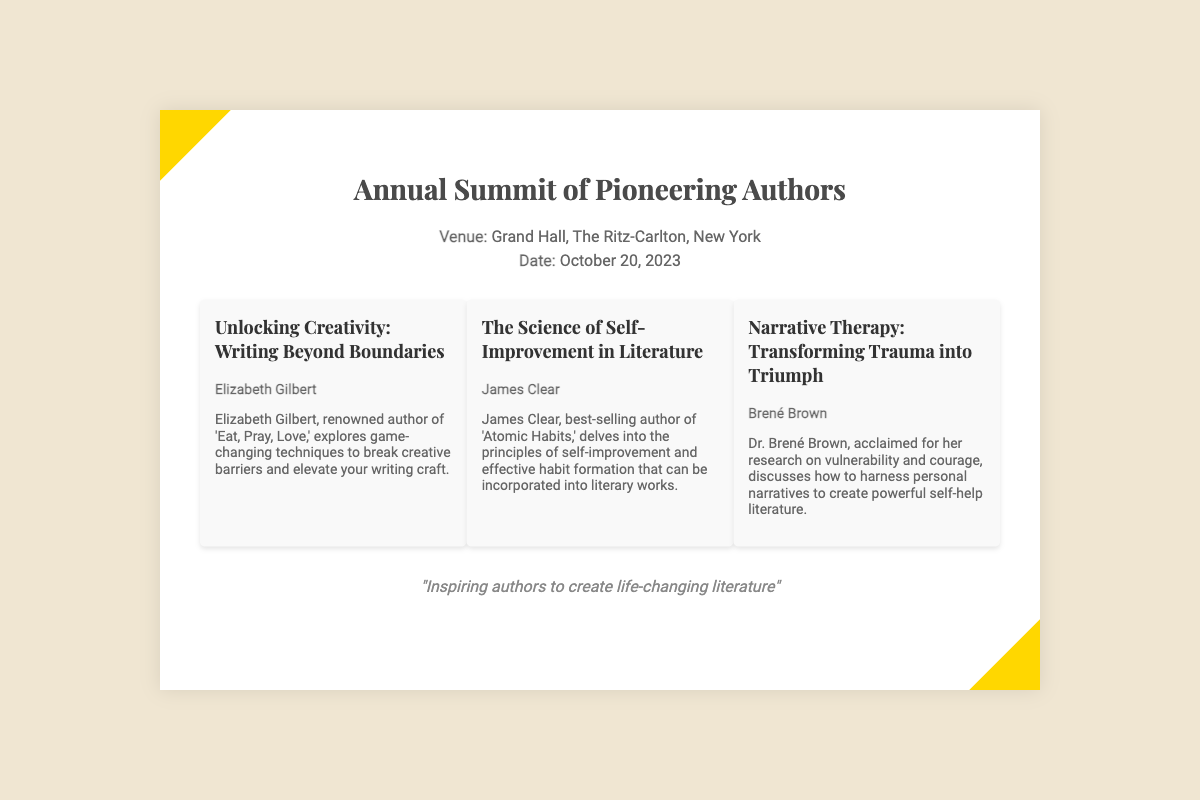What is the name of the event? The event is titled "Annual Summit of Pioneering Authors" as stated at the top of the document.
Answer: Annual Summit of Pioneering Authors Where is the event taking place? The venue is mentioned as "Grand Hall, The Ritz-Carlton, New York" in the document.
Answer: Grand Hall, The Ritz-Carlton, New York What date is the event scheduled for? The date is specified as "October 20, 2023" within the event details section.
Answer: October 20, 2023 Who is the speaker for the keynote on creativity? The keynote on creativity is presented by Elizabeth Gilbert, as indicated in the keynote section.
Answer: Elizabeth Gilbert What is the main topic of James Clear's keynote? James Clear's keynote focuses on "The Science of Self-Improvement in Literature" according to the document.
Answer: The Science of Self-Improvement in Literature How many keynote speakers are mentioned? There are three keynote speakers listed in the document, as seen in the keynotes section.
Answer: Three What kind of literature does Brené Brown focus on? Brené Brown discusses "Transforming Trauma into Triumph" in her keynote, related to self-help literature.
Answer: Self-help literature What is the theme of the document? The theme centers around inspiring authors to create impactful literature, as conveyed in the footer.
Answer: Inspiring authors to create life-changing literature 